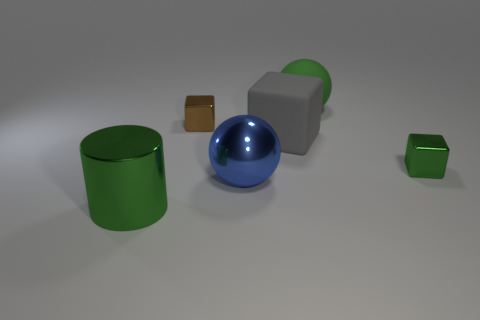What does the arrangement of the objects tell us about the purpose of this image? The arrangement of the objects—each separated with space, neither overlapping nor touching—suggests that this image could be designed for demonstration purposes, perhaps to showcase the render quality of different material surfaces and how light interacts with them. It feels like a scene from a 3D modeling software or a graphics test rather than a functional setup. 